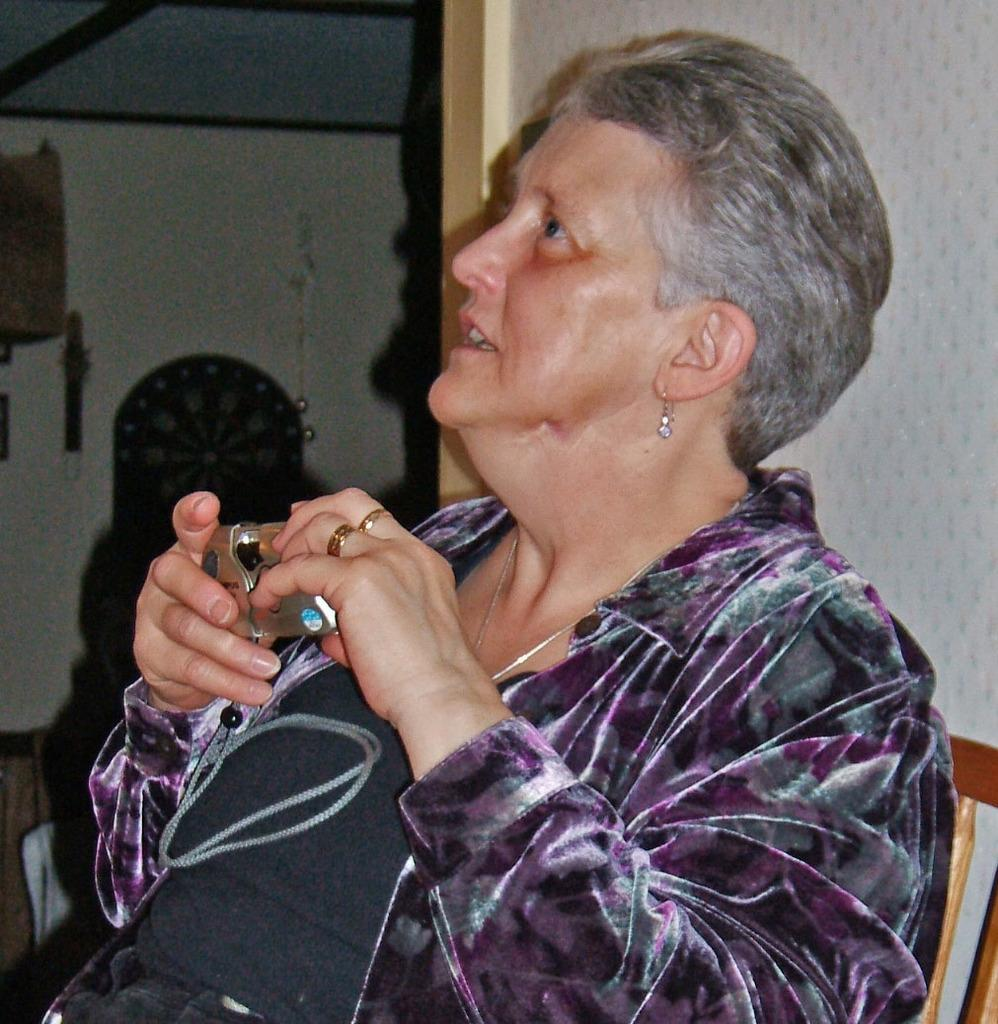Who is the main subject in the image? There is a woman in the image. What is the woman doing in the image? The woman is sitting on a chair and holding a camera in her hands. What can be seen in the background of the image? There is a wall in the background of the image. Can you see a ghost in the image? No, there is no ghost present in the image. What type of train can be seen in the background of the image? There is no train present in the image; it only features a woman sitting on a chair and a wall in the background. 